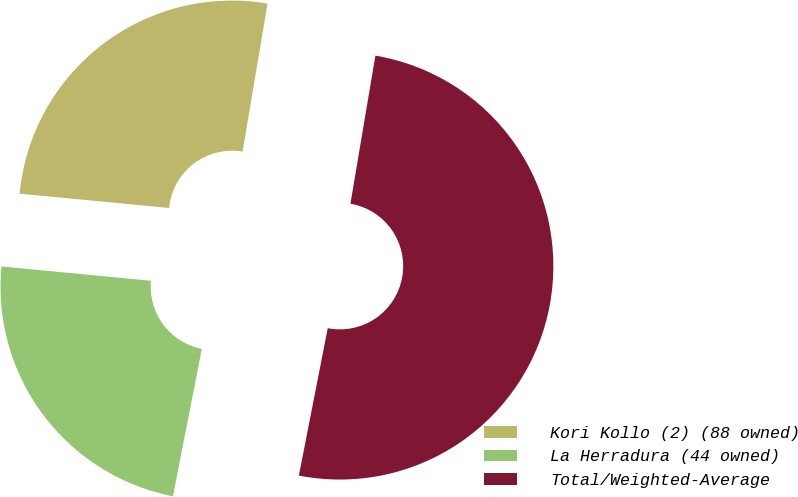Convert chart. <chart><loc_0><loc_0><loc_500><loc_500><pie_chart><fcel>Kori Kollo (2) (88 owned)<fcel>La Herradura (44 owned)<fcel>Total/Weighted-Average<nl><fcel>26.14%<fcel>23.44%<fcel>50.42%<nl></chart> 